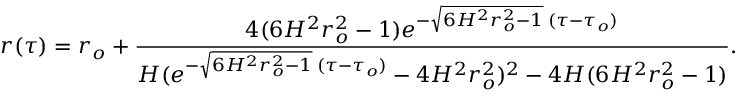Convert formula to latex. <formula><loc_0><loc_0><loc_500><loc_500>r ( \tau ) = r _ { o } + \frac { 4 ( 6 H ^ { 2 } r _ { o } ^ { 2 } - 1 ) e ^ { - \sqrt { 6 H ^ { 2 } r _ { o } ^ { 2 } - 1 } \, ( \tau - \tau _ { o } ) } } { H ( e ^ { - \sqrt { 6 H ^ { 2 } r _ { o } ^ { 2 } - 1 } \, ( \tau - \tau _ { o } ) } - 4 H ^ { 2 } r _ { o } ^ { 2 } ) ^ { 2 } - 4 H ( 6 H ^ { 2 } r _ { o } ^ { 2 } - 1 ) } .</formula> 